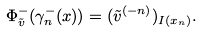<formula> <loc_0><loc_0><loc_500><loc_500>\Phi ^ { - } _ { \tilde { v } } ( \gamma _ { n } ^ { - } ( x ) ) = ( { \tilde { v } } ^ { ( - n ) } ) _ { I ( x _ { n } ) } .</formula> 